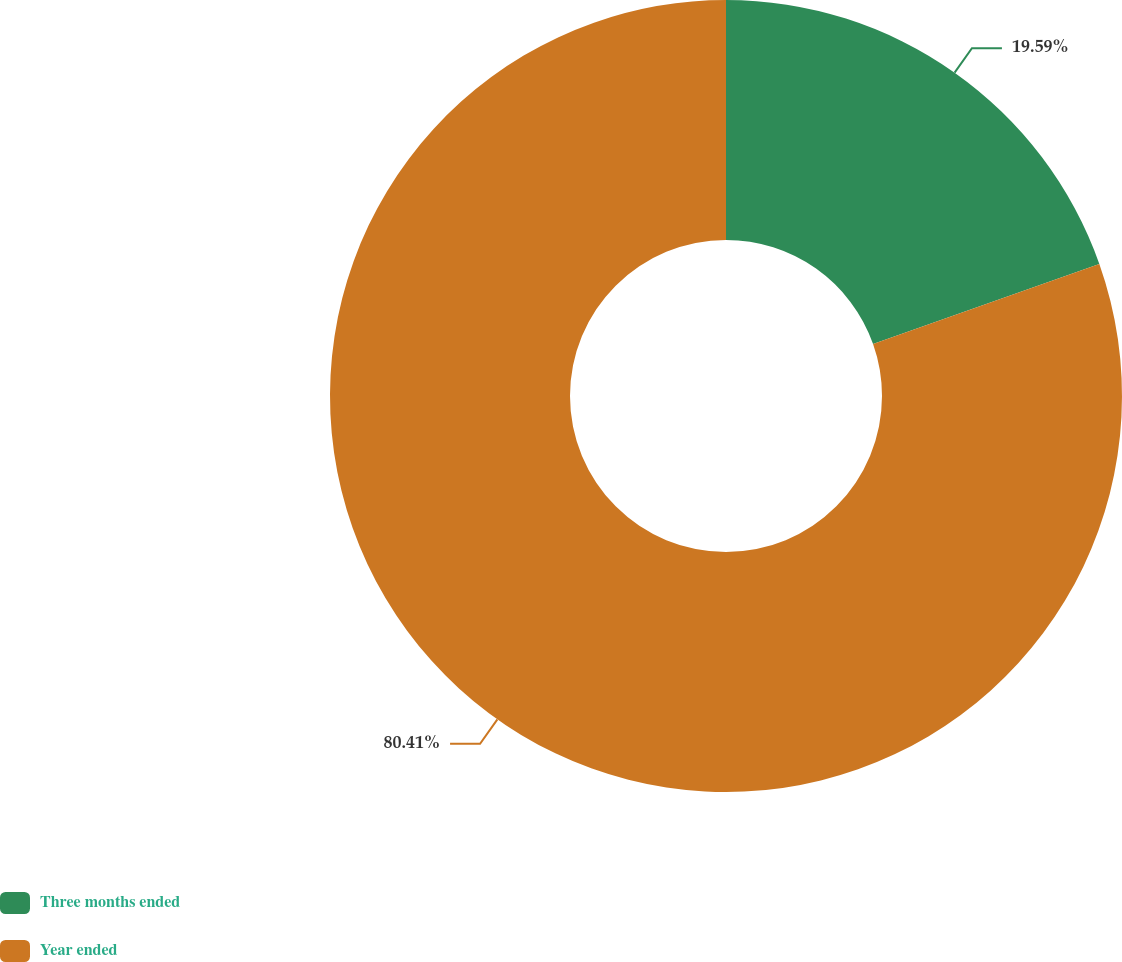<chart> <loc_0><loc_0><loc_500><loc_500><pie_chart><fcel>Three months ended<fcel>Year ended<nl><fcel>19.59%<fcel>80.41%<nl></chart> 